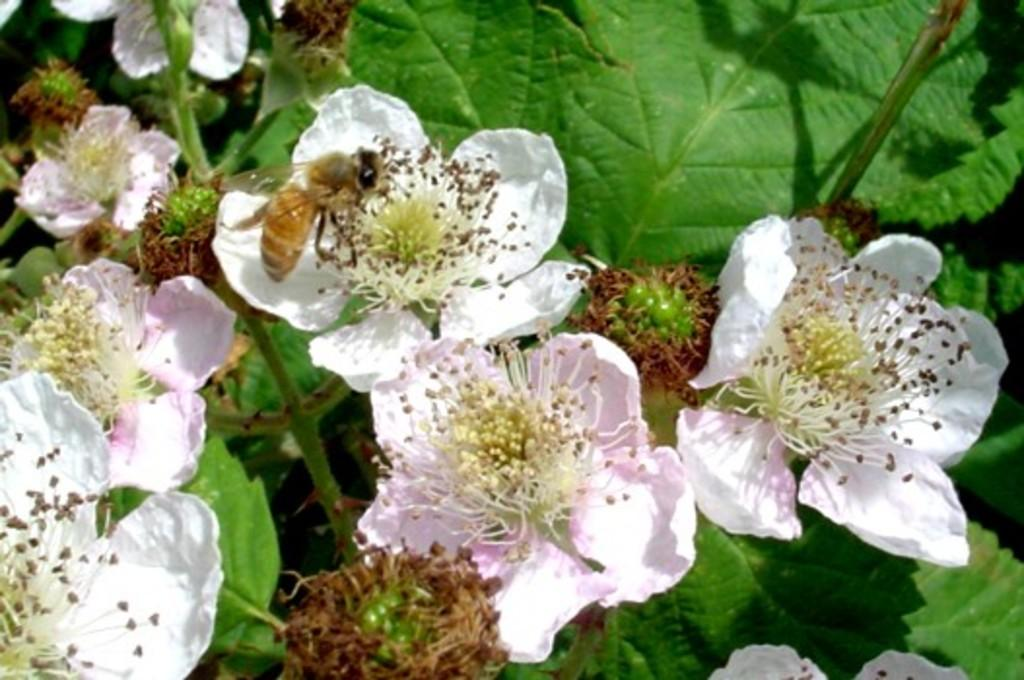What type of creature can be seen in the image? There is an insect in the image. What type of plants are present in the image? There are flowers, leaves, and stems in the image. Can you describe the unspecified things in the image? Unfortunately, the facts provided do not specify what these unspecified things are. What type of wound can be seen on the insect in the image? There is no wound visible on the insect in the image. What type of brass object is present in the image? There is no brass object present in the image. 